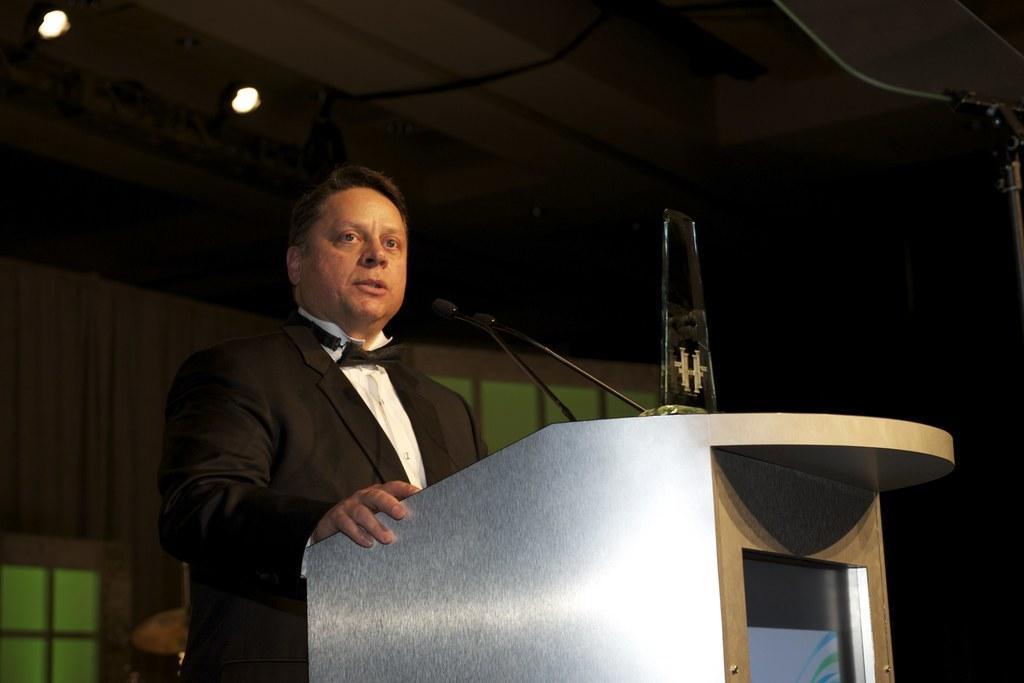Can you describe this image briefly? In this image I can see the person standing in-front of the podium. On the podium I can see the mics. The person is wearing the white and black color dress. I can see some lights in the top. 